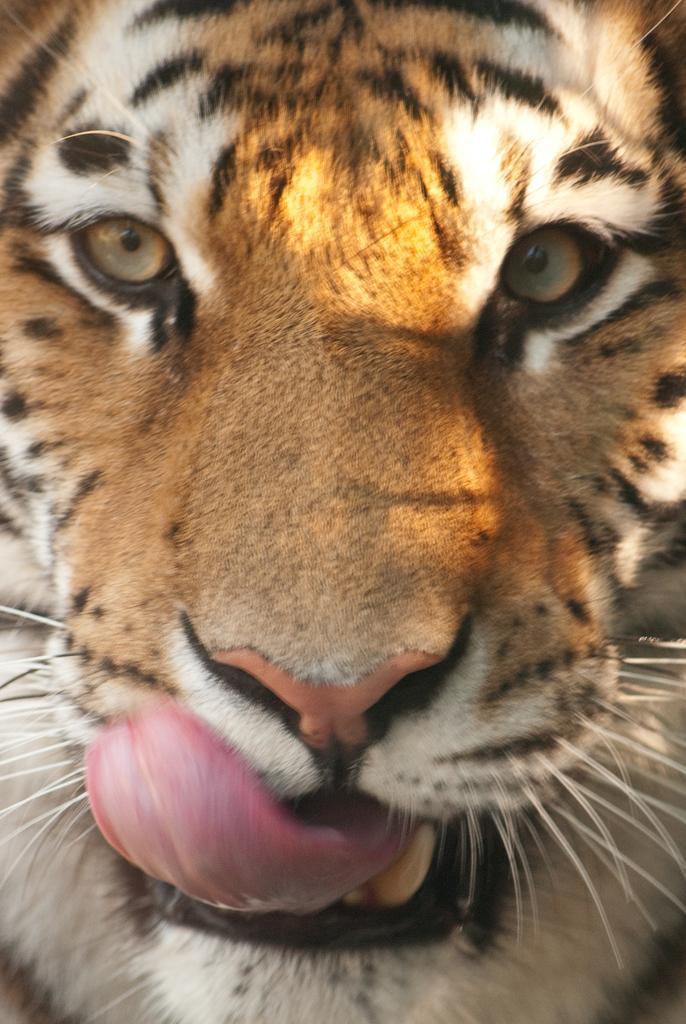Please provide a concise description of this image. In the image there is a tiger with its tongue outside. 